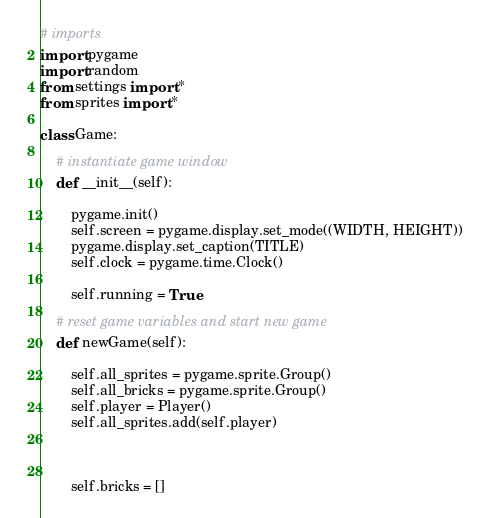Convert code to text. <code><loc_0><loc_0><loc_500><loc_500><_Python_># imports
import pygame
import random
from settings import *
from sprites import *

class Game:
	
	# instantiate game window
	def __init__(self):

		pygame.init()
		self.screen = pygame.display.set_mode((WIDTH, HEIGHT))
		pygame.display.set_caption(TITLE)
		self.clock = pygame.time.Clock()

		self.running = True

	# reset game variables and start new game
	def newGame(self):
		
		self.all_sprites = pygame.sprite.Group()
		self.all_bricks = pygame.sprite.Group()
		self.player = Player()
		self.all_sprites.add(self.player)
		
		

		self.bricks = []
</code> 